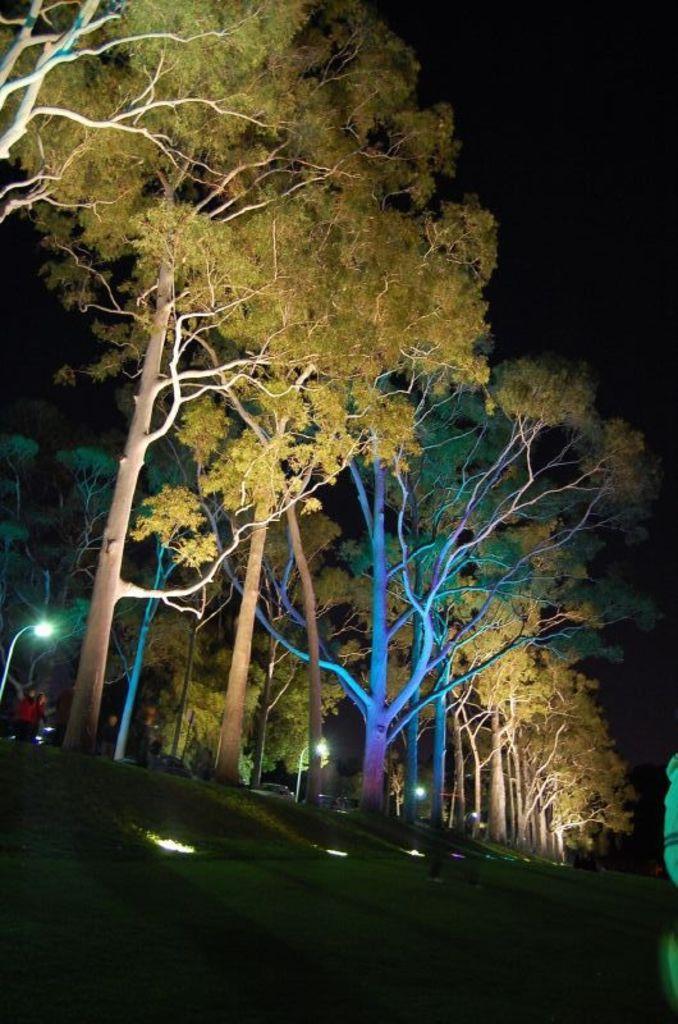Could you give a brief overview of what you see in this image? At the bottom of the image there are lights. In the center we can see trees. On the left there is a person. 